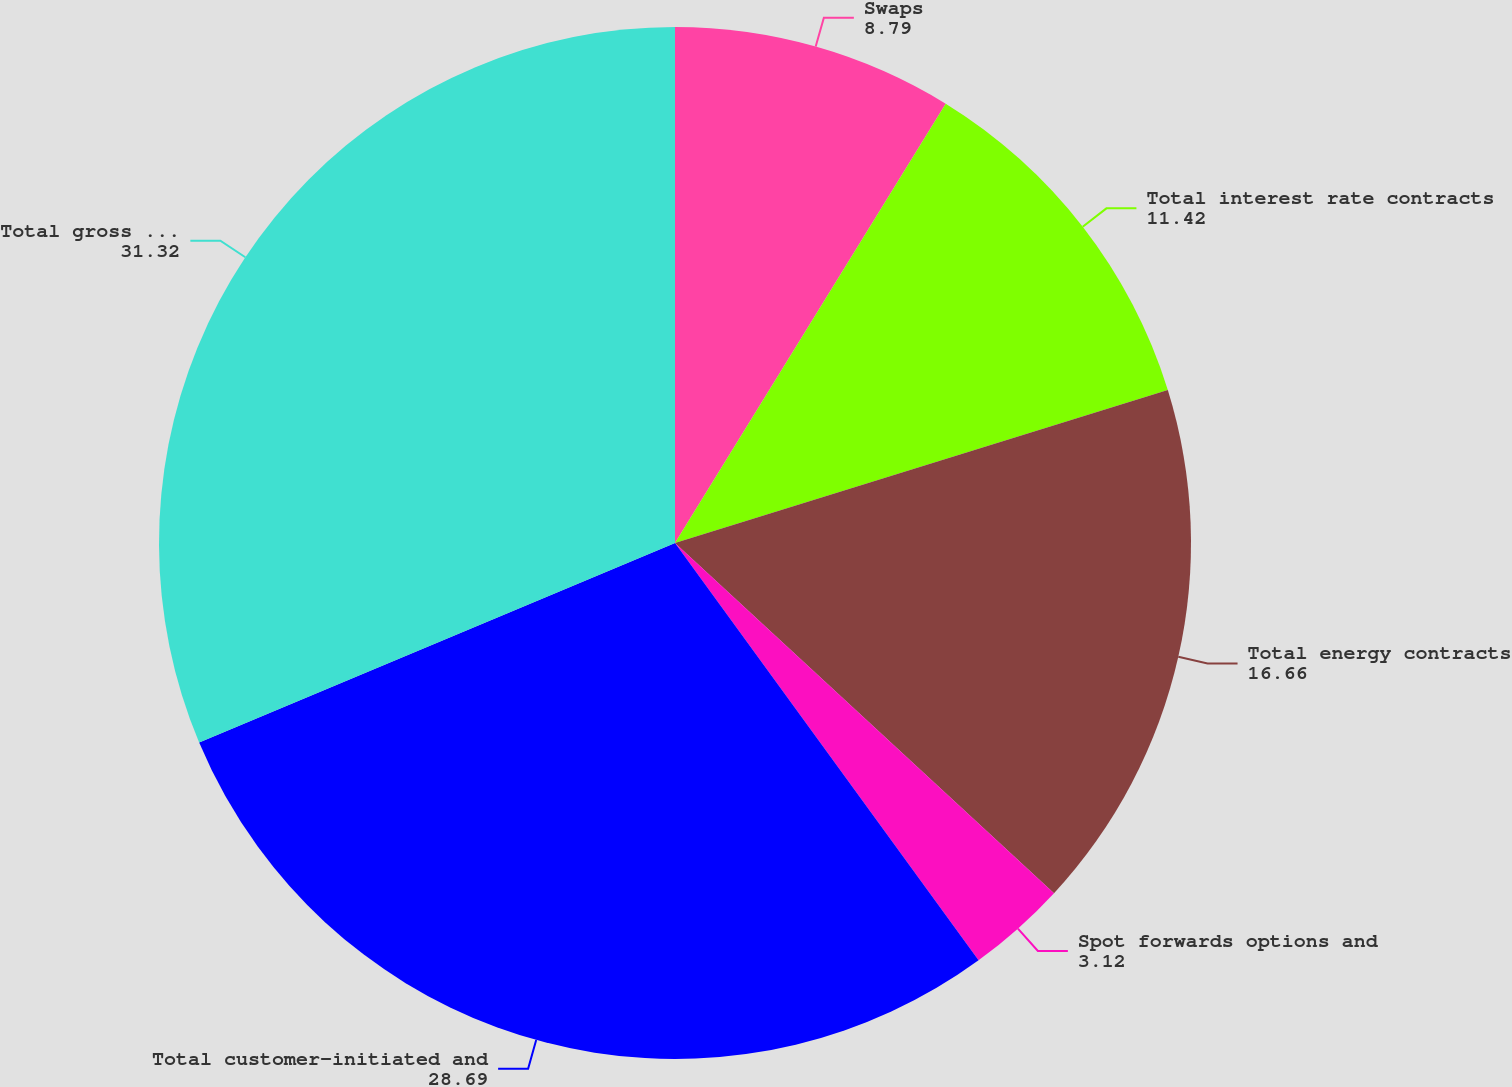Convert chart. <chart><loc_0><loc_0><loc_500><loc_500><pie_chart><fcel>Swaps<fcel>Total interest rate contracts<fcel>Total energy contracts<fcel>Spot forwards options and<fcel>Total customer-initiated and<fcel>Total gross derivatives<nl><fcel>8.79%<fcel>11.42%<fcel>16.66%<fcel>3.12%<fcel>28.69%<fcel>31.32%<nl></chart> 